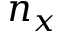Convert formula to latex. <formula><loc_0><loc_0><loc_500><loc_500>n _ { x }</formula> 